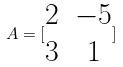<formula> <loc_0><loc_0><loc_500><loc_500>A = [ \begin{matrix} 2 & - 5 \\ 3 & 1 \\ \end{matrix} ]</formula> 